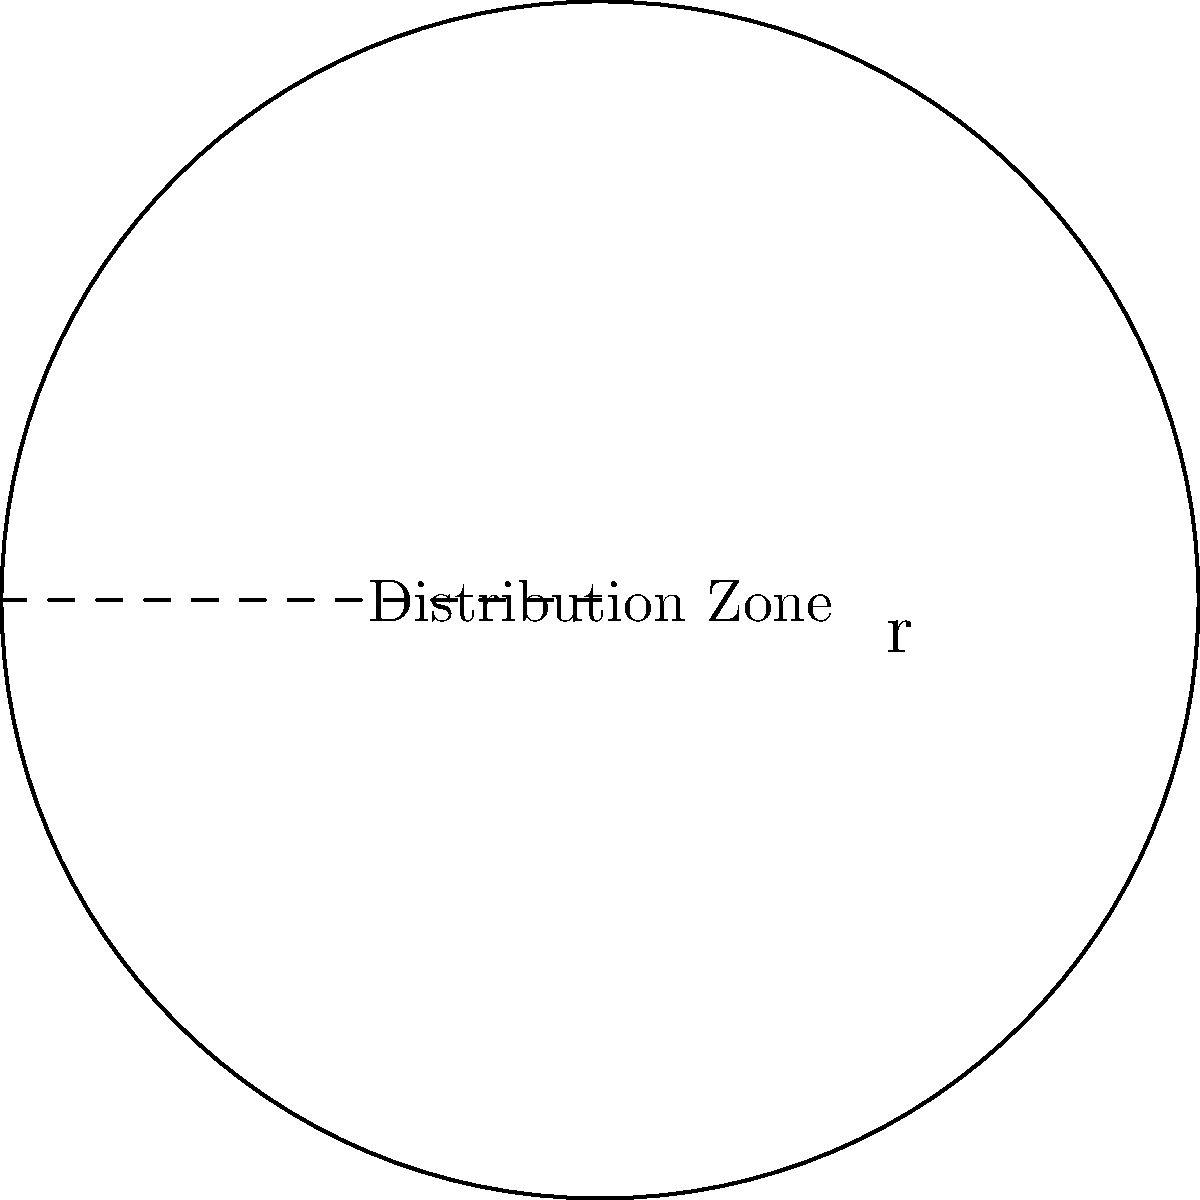As a community leader, you're organizing an aid distribution zone in a circular area. If the radius of this zone is 300 meters, what is the perimeter of the distribution area? Round your answer to the nearest meter. To solve this problem, we need to follow these steps:

1. Recall the formula for the circumference (perimeter) of a circle:
   $$C = 2\pi r$$
   where $C$ is the circumference, $\pi$ is pi, and $r$ is the radius.

2. We're given that the radius is 300 meters. Let's substitute this into our formula:
   $$C = 2\pi (300)$$

3. Now, let's calculate:
   $$C = 2 \times 3.14159... \times 300$$

4. Multiply:
   $$C = 1884.95... \text{ meters}$$

5. Rounding to the nearest meter:
   $$C \approx 1885 \text{ meters}$$

Therefore, the perimeter of the circular distribution zone is approximately 1885 meters.
Answer: 1885 meters 